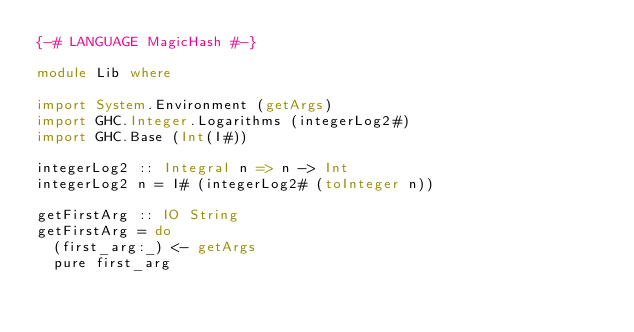<code> <loc_0><loc_0><loc_500><loc_500><_Haskell_>{-# LANGUAGE MagicHash #-}

module Lib where

import System.Environment (getArgs)
import GHC.Integer.Logarithms (integerLog2#)
import GHC.Base (Int(I#))

integerLog2 :: Integral n => n -> Int
integerLog2 n = I# (integerLog2# (toInteger n))

getFirstArg :: IO String
getFirstArg = do
  (first_arg:_) <- getArgs
  pure first_arg
</code> 